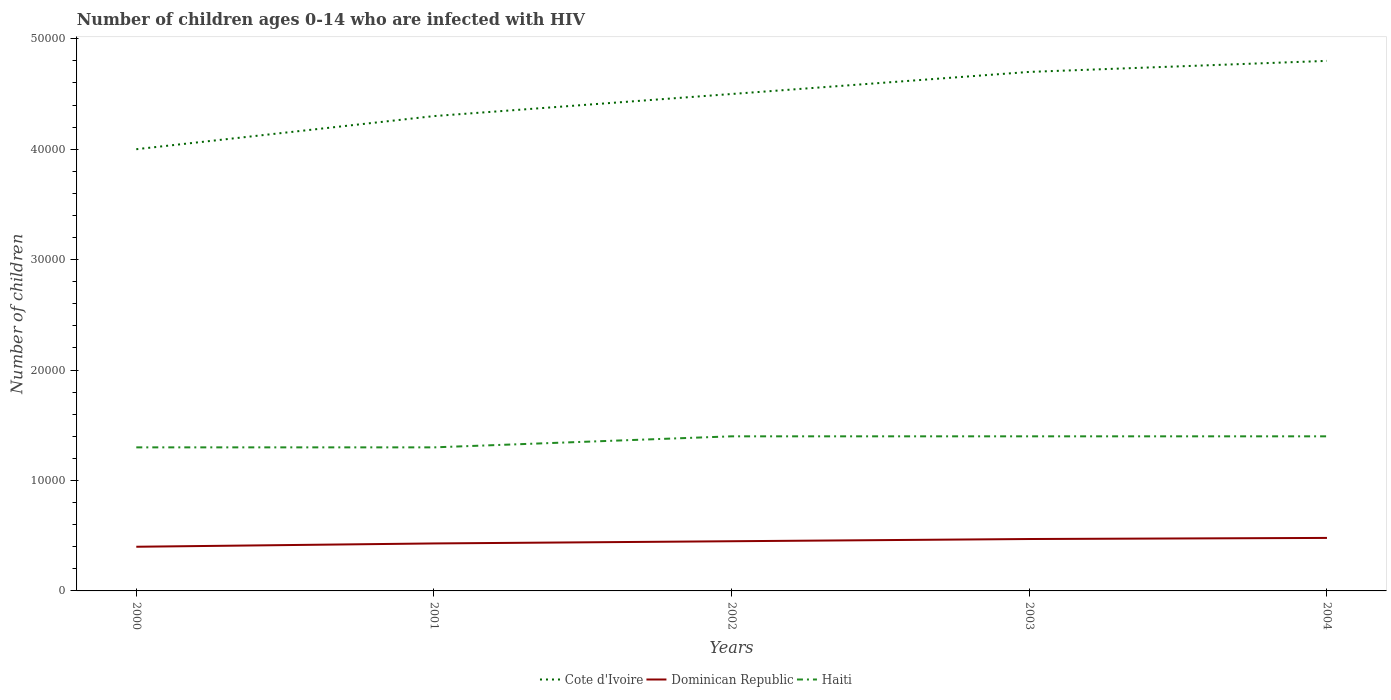How many different coloured lines are there?
Your answer should be very brief. 3. Is the number of lines equal to the number of legend labels?
Offer a terse response. Yes. Across all years, what is the maximum number of HIV infected children in Cote d'Ivoire?
Make the answer very short. 4.00e+04. In which year was the number of HIV infected children in Dominican Republic maximum?
Provide a short and direct response. 2000. What is the total number of HIV infected children in Cote d'Ivoire in the graph?
Give a very brief answer. -5000. What is the difference between the highest and the second highest number of HIV infected children in Cote d'Ivoire?
Your answer should be very brief. 8000. What is the difference between the highest and the lowest number of HIV infected children in Cote d'Ivoire?
Your response must be concise. 3. How many lines are there?
Keep it short and to the point. 3. How many years are there in the graph?
Offer a very short reply. 5. Does the graph contain any zero values?
Provide a succinct answer. No. What is the title of the graph?
Make the answer very short. Number of children ages 0-14 who are infected with HIV. Does "Low & middle income" appear as one of the legend labels in the graph?
Offer a very short reply. No. What is the label or title of the Y-axis?
Keep it short and to the point. Number of children. What is the Number of children of Cote d'Ivoire in 2000?
Your answer should be very brief. 4.00e+04. What is the Number of children of Dominican Republic in 2000?
Provide a short and direct response. 4000. What is the Number of children of Haiti in 2000?
Your answer should be very brief. 1.30e+04. What is the Number of children of Cote d'Ivoire in 2001?
Ensure brevity in your answer.  4.30e+04. What is the Number of children of Dominican Republic in 2001?
Keep it short and to the point. 4300. What is the Number of children of Haiti in 2001?
Offer a terse response. 1.30e+04. What is the Number of children in Cote d'Ivoire in 2002?
Make the answer very short. 4.50e+04. What is the Number of children in Dominican Republic in 2002?
Provide a succinct answer. 4500. What is the Number of children of Haiti in 2002?
Your answer should be compact. 1.40e+04. What is the Number of children in Cote d'Ivoire in 2003?
Your answer should be very brief. 4.70e+04. What is the Number of children of Dominican Republic in 2003?
Offer a very short reply. 4700. What is the Number of children of Haiti in 2003?
Your answer should be very brief. 1.40e+04. What is the Number of children in Cote d'Ivoire in 2004?
Offer a terse response. 4.80e+04. What is the Number of children of Dominican Republic in 2004?
Provide a succinct answer. 4800. What is the Number of children in Haiti in 2004?
Provide a succinct answer. 1.40e+04. Across all years, what is the maximum Number of children in Cote d'Ivoire?
Your answer should be compact. 4.80e+04. Across all years, what is the maximum Number of children of Dominican Republic?
Provide a succinct answer. 4800. Across all years, what is the maximum Number of children in Haiti?
Your answer should be compact. 1.40e+04. Across all years, what is the minimum Number of children of Dominican Republic?
Give a very brief answer. 4000. Across all years, what is the minimum Number of children in Haiti?
Make the answer very short. 1.30e+04. What is the total Number of children of Cote d'Ivoire in the graph?
Give a very brief answer. 2.23e+05. What is the total Number of children of Dominican Republic in the graph?
Offer a terse response. 2.23e+04. What is the total Number of children in Haiti in the graph?
Give a very brief answer. 6.80e+04. What is the difference between the Number of children in Cote d'Ivoire in 2000 and that in 2001?
Ensure brevity in your answer.  -3000. What is the difference between the Number of children in Dominican Republic in 2000 and that in 2001?
Give a very brief answer. -300. What is the difference between the Number of children in Cote d'Ivoire in 2000 and that in 2002?
Give a very brief answer. -5000. What is the difference between the Number of children in Dominican Republic in 2000 and that in 2002?
Keep it short and to the point. -500. What is the difference between the Number of children of Haiti in 2000 and that in 2002?
Offer a very short reply. -1000. What is the difference between the Number of children in Cote d'Ivoire in 2000 and that in 2003?
Make the answer very short. -7000. What is the difference between the Number of children of Dominican Republic in 2000 and that in 2003?
Give a very brief answer. -700. What is the difference between the Number of children of Haiti in 2000 and that in 2003?
Your answer should be very brief. -1000. What is the difference between the Number of children in Cote d'Ivoire in 2000 and that in 2004?
Offer a terse response. -8000. What is the difference between the Number of children in Dominican Republic in 2000 and that in 2004?
Your response must be concise. -800. What is the difference between the Number of children of Haiti in 2000 and that in 2004?
Provide a succinct answer. -1000. What is the difference between the Number of children in Cote d'Ivoire in 2001 and that in 2002?
Make the answer very short. -2000. What is the difference between the Number of children of Dominican Republic in 2001 and that in 2002?
Keep it short and to the point. -200. What is the difference between the Number of children in Haiti in 2001 and that in 2002?
Offer a very short reply. -1000. What is the difference between the Number of children in Cote d'Ivoire in 2001 and that in 2003?
Keep it short and to the point. -4000. What is the difference between the Number of children of Dominican Republic in 2001 and that in 2003?
Your answer should be compact. -400. What is the difference between the Number of children of Haiti in 2001 and that in 2003?
Your answer should be very brief. -1000. What is the difference between the Number of children in Cote d'Ivoire in 2001 and that in 2004?
Provide a short and direct response. -5000. What is the difference between the Number of children in Dominican Republic in 2001 and that in 2004?
Offer a very short reply. -500. What is the difference between the Number of children of Haiti in 2001 and that in 2004?
Give a very brief answer. -1000. What is the difference between the Number of children of Cote d'Ivoire in 2002 and that in 2003?
Ensure brevity in your answer.  -2000. What is the difference between the Number of children in Dominican Republic in 2002 and that in 2003?
Ensure brevity in your answer.  -200. What is the difference between the Number of children in Cote d'Ivoire in 2002 and that in 2004?
Your answer should be compact. -3000. What is the difference between the Number of children of Dominican Republic in 2002 and that in 2004?
Your response must be concise. -300. What is the difference between the Number of children of Cote d'Ivoire in 2003 and that in 2004?
Provide a succinct answer. -1000. What is the difference between the Number of children of Dominican Republic in 2003 and that in 2004?
Offer a terse response. -100. What is the difference between the Number of children in Haiti in 2003 and that in 2004?
Provide a succinct answer. 0. What is the difference between the Number of children in Cote d'Ivoire in 2000 and the Number of children in Dominican Republic in 2001?
Provide a short and direct response. 3.57e+04. What is the difference between the Number of children of Cote d'Ivoire in 2000 and the Number of children of Haiti in 2001?
Your answer should be very brief. 2.70e+04. What is the difference between the Number of children of Dominican Republic in 2000 and the Number of children of Haiti in 2001?
Provide a short and direct response. -9000. What is the difference between the Number of children in Cote d'Ivoire in 2000 and the Number of children in Dominican Republic in 2002?
Your response must be concise. 3.55e+04. What is the difference between the Number of children of Cote d'Ivoire in 2000 and the Number of children of Haiti in 2002?
Ensure brevity in your answer.  2.60e+04. What is the difference between the Number of children in Cote d'Ivoire in 2000 and the Number of children in Dominican Republic in 2003?
Your answer should be very brief. 3.53e+04. What is the difference between the Number of children of Cote d'Ivoire in 2000 and the Number of children of Haiti in 2003?
Offer a very short reply. 2.60e+04. What is the difference between the Number of children in Dominican Republic in 2000 and the Number of children in Haiti in 2003?
Your response must be concise. -10000. What is the difference between the Number of children of Cote d'Ivoire in 2000 and the Number of children of Dominican Republic in 2004?
Your answer should be compact. 3.52e+04. What is the difference between the Number of children in Cote d'Ivoire in 2000 and the Number of children in Haiti in 2004?
Offer a terse response. 2.60e+04. What is the difference between the Number of children in Cote d'Ivoire in 2001 and the Number of children in Dominican Republic in 2002?
Offer a very short reply. 3.85e+04. What is the difference between the Number of children in Cote d'Ivoire in 2001 and the Number of children in Haiti in 2002?
Offer a very short reply. 2.90e+04. What is the difference between the Number of children in Dominican Republic in 2001 and the Number of children in Haiti in 2002?
Provide a succinct answer. -9700. What is the difference between the Number of children in Cote d'Ivoire in 2001 and the Number of children in Dominican Republic in 2003?
Offer a terse response. 3.83e+04. What is the difference between the Number of children of Cote d'Ivoire in 2001 and the Number of children of Haiti in 2003?
Provide a short and direct response. 2.90e+04. What is the difference between the Number of children of Dominican Republic in 2001 and the Number of children of Haiti in 2003?
Provide a short and direct response. -9700. What is the difference between the Number of children in Cote d'Ivoire in 2001 and the Number of children in Dominican Republic in 2004?
Offer a terse response. 3.82e+04. What is the difference between the Number of children in Cote d'Ivoire in 2001 and the Number of children in Haiti in 2004?
Offer a terse response. 2.90e+04. What is the difference between the Number of children in Dominican Republic in 2001 and the Number of children in Haiti in 2004?
Your answer should be very brief. -9700. What is the difference between the Number of children in Cote d'Ivoire in 2002 and the Number of children in Dominican Republic in 2003?
Offer a very short reply. 4.03e+04. What is the difference between the Number of children of Cote d'Ivoire in 2002 and the Number of children of Haiti in 2003?
Keep it short and to the point. 3.10e+04. What is the difference between the Number of children of Dominican Republic in 2002 and the Number of children of Haiti in 2003?
Offer a terse response. -9500. What is the difference between the Number of children in Cote d'Ivoire in 2002 and the Number of children in Dominican Republic in 2004?
Give a very brief answer. 4.02e+04. What is the difference between the Number of children in Cote d'Ivoire in 2002 and the Number of children in Haiti in 2004?
Ensure brevity in your answer.  3.10e+04. What is the difference between the Number of children of Dominican Republic in 2002 and the Number of children of Haiti in 2004?
Ensure brevity in your answer.  -9500. What is the difference between the Number of children of Cote d'Ivoire in 2003 and the Number of children of Dominican Republic in 2004?
Ensure brevity in your answer.  4.22e+04. What is the difference between the Number of children in Cote d'Ivoire in 2003 and the Number of children in Haiti in 2004?
Your answer should be compact. 3.30e+04. What is the difference between the Number of children in Dominican Republic in 2003 and the Number of children in Haiti in 2004?
Provide a short and direct response. -9300. What is the average Number of children in Cote d'Ivoire per year?
Offer a very short reply. 4.46e+04. What is the average Number of children in Dominican Republic per year?
Your answer should be compact. 4460. What is the average Number of children of Haiti per year?
Ensure brevity in your answer.  1.36e+04. In the year 2000, what is the difference between the Number of children of Cote d'Ivoire and Number of children of Dominican Republic?
Your answer should be compact. 3.60e+04. In the year 2000, what is the difference between the Number of children of Cote d'Ivoire and Number of children of Haiti?
Provide a short and direct response. 2.70e+04. In the year 2000, what is the difference between the Number of children of Dominican Republic and Number of children of Haiti?
Keep it short and to the point. -9000. In the year 2001, what is the difference between the Number of children in Cote d'Ivoire and Number of children in Dominican Republic?
Ensure brevity in your answer.  3.87e+04. In the year 2001, what is the difference between the Number of children of Cote d'Ivoire and Number of children of Haiti?
Your answer should be compact. 3.00e+04. In the year 2001, what is the difference between the Number of children in Dominican Republic and Number of children in Haiti?
Your response must be concise. -8700. In the year 2002, what is the difference between the Number of children in Cote d'Ivoire and Number of children in Dominican Republic?
Provide a short and direct response. 4.05e+04. In the year 2002, what is the difference between the Number of children in Cote d'Ivoire and Number of children in Haiti?
Offer a terse response. 3.10e+04. In the year 2002, what is the difference between the Number of children of Dominican Republic and Number of children of Haiti?
Your answer should be very brief. -9500. In the year 2003, what is the difference between the Number of children in Cote d'Ivoire and Number of children in Dominican Republic?
Provide a short and direct response. 4.23e+04. In the year 2003, what is the difference between the Number of children of Cote d'Ivoire and Number of children of Haiti?
Your response must be concise. 3.30e+04. In the year 2003, what is the difference between the Number of children of Dominican Republic and Number of children of Haiti?
Your answer should be very brief. -9300. In the year 2004, what is the difference between the Number of children of Cote d'Ivoire and Number of children of Dominican Republic?
Provide a short and direct response. 4.32e+04. In the year 2004, what is the difference between the Number of children of Cote d'Ivoire and Number of children of Haiti?
Your answer should be very brief. 3.40e+04. In the year 2004, what is the difference between the Number of children in Dominican Republic and Number of children in Haiti?
Give a very brief answer. -9200. What is the ratio of the Number of children of Cote d'Ivoire in 2000 to that in 2001?
Make the answer very short. 0.93. What is the ratio of the Number of children of Dominican Republic in 2000 to that in 2001?
Ensure brevity in your answer.  0.93. What is the ratio of the Number of children in Haiti in 2000 to that in 2001?
Provide a succinct answer. 1. What is the ratio of the Number of children of Cote d'Ivoire in 2000 to that in 2003?
Provide a short and direct response. 0.85. What is the ratio of the Number of children in Dominican Republic in 2000 to that in 2003?
Your answer should be very brief. 0.85. What is the ratio of the Number of children in Haiti in 2000 to that in 2003?
Offer a terse response. 0.93. What is the ratio of the Number of children of Cote d'Ivoire in 2000 to that in 2004?
Your answer should be compact. 0.83. What is the ratio of the Number of children in Haiti in 2000 to that in 2004?
Give a very brief answer. 0.93. What is the ratio of the Number of children of Cote d'Ivoire in 2001 to that in 2002?
Keep it short and to the point. 0.96. What is the ratio of the Number of children of Dominican Republic in 2001 to that in 2002?
Your answer should be compact. 0.96. What is the ratio of the Number of children of Haiti in 2001 to that in 2002?
Your answer should be compact. 0.93. What is the ratio of the Number of children in Cote d'Ivoire in 2001 to that in 2003?
Give a very brief answer. 0.91. What is the ratio of the Number of children of Dominican Republic in 2001 to that in 2003?
Provide a succinct answer. 0.91. What is the ratio of the Number of children in Cote d'Ivoire in 2001 to that in 2004?
Offer a terse response. 0.9. What is the ratio of the Number of children in Dominican Republic in 2001 to that in 2004?
Provide a succinct answer. 0.9. What is the ratio of the Number of children in Cote d'Ivoire in 2002 to that in 2003?
Provide a succinct answer. 0.96. What is the ratio of the Number of children of Dominican Republic in 2002 to that in 2003?
Keep it short and to the point. 0.96. What is the ratio of the Number of children in Haiti in 2002 to that in 2003?
Your response must be concise. 1. What is the ratio of the Number of children in Cote d'Ivoire in 2002 to that in 2004?
Your answer should be very brief. 0.94. What is the ratio of the Number of children in Dominican Republic in 2002 to that in 2004?
Ensure brevity in your answer.  0.94. What is the ratio of the Number of children of Cote d'Ivoire in 2003 to that in 2004?
Provide a short and direct response. 0.98. What is the ratio of the Number of children of Dominican Republic in 2003 to that in 2004?
Your answer should be compact. 0.98. What is the ratio of the Number of children of Haiti in 2003 to that in 2004?
Your response must be concise. 1. What is the difference between the highest and the second highest Number of children of Cote d'Ivoire?
Ensure brevity in your answer.  1000. What is the difference between the highest and the second highest Number of children of Dominican Republic?
Provide a succinct answer. 100. What is the difference between the highest and the lowest Number of children in Cote d'Ivoire?
Your answer should be very brief. 8000. What is the difference between the highest and the lowest Number of children of Dominican Republic?
Your answer should be very brief. 800. What is the difference between the highest and the lowest Number of children in Haiti?
Your answer should be very brief. 1000. 